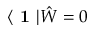<formula> <loc_0><loc_0><loc_500><loc_500>\langle 1 | \hat { W } = 0</formula> 